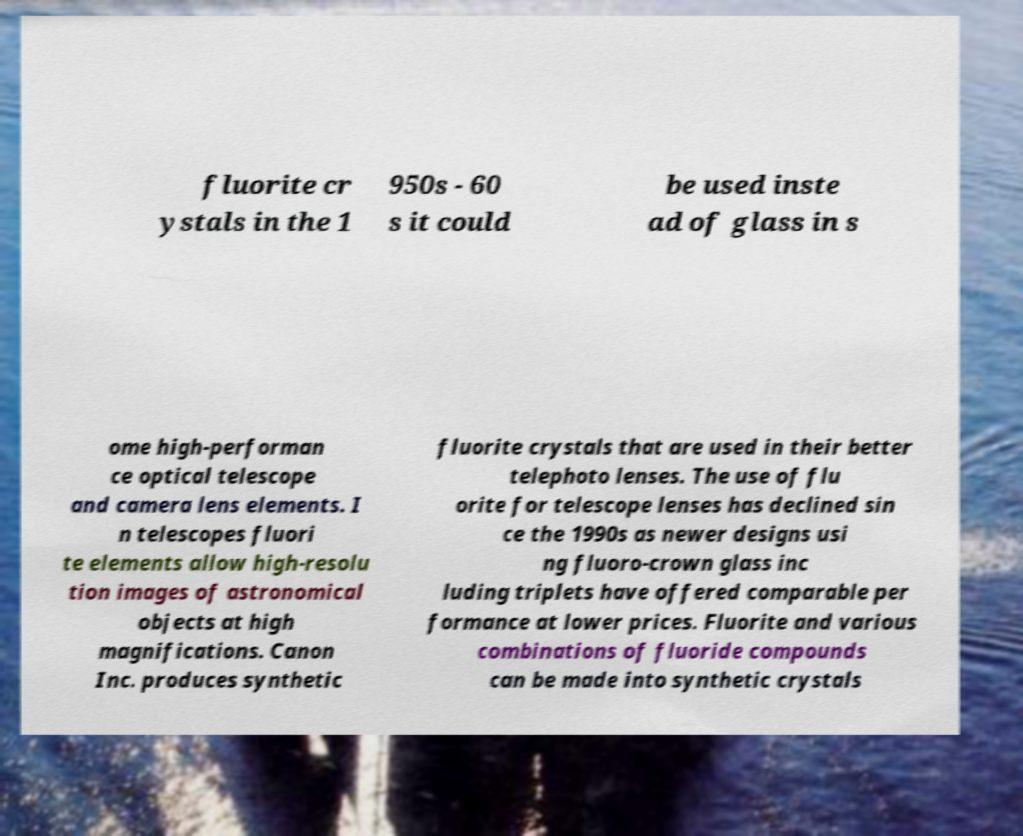Can you read and provide the text displayed in the image?This photo seems to have some interesting text. Can you extract and type it out for me? fluorite cr ystals in the 1 950s - 60 s it could be used inste ad of glass in s ome high-performan ce optical telescope and camera lens elements. I n telescopes fluori te elements allow high-resolu tion images of astronomical objects at high magnifications. Canon Inc. produces synthetic fluorite crystals that are used in their better telephoto lenses. The use of flu orite for telescope lenses has declined sin ce the 1990s as newer designs usi ng fluoro-crown glass inc luding triplets have offered comparable per formance at lower prices. Fluorite and various combinations of fluoride compounds can be made into synthetic crystals 